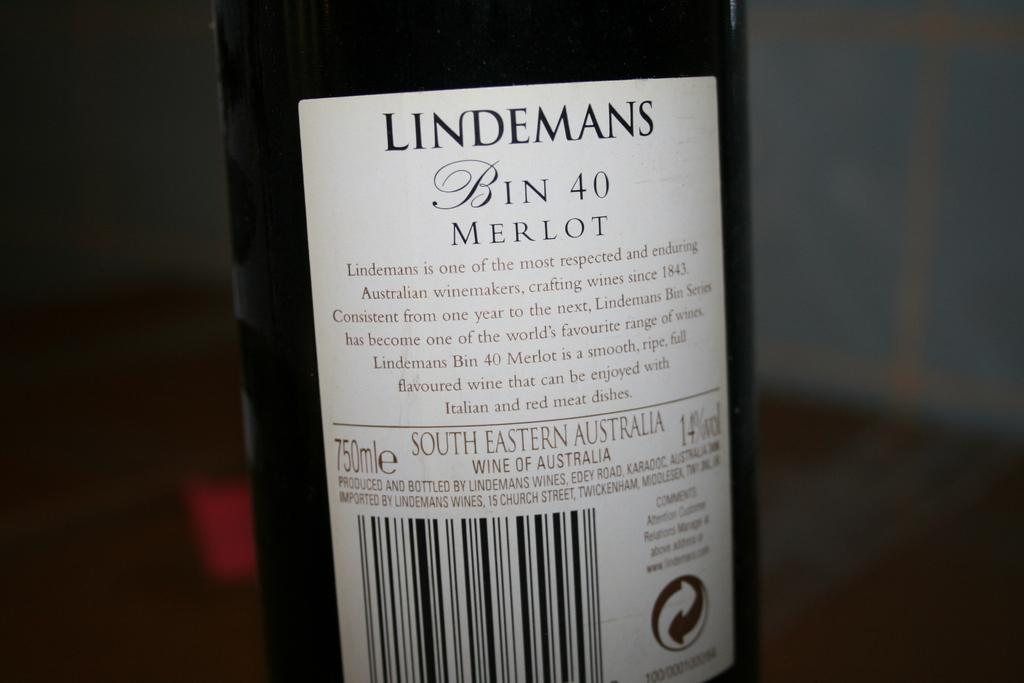Provide a one-sentence caption for the provided image. The back of a wine bottle with the brand name Lindemans. 